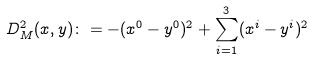<formula> <loc_0><loc_0><loc_500><loc_500>D ^ { 2 } _ { M } ( x , y ) \colon = - ( x ^ { 0 } - y ^ { 0 } ) ^ { 2 } + \sum _ { i = 1 } ^ { 3 } ( x ^ { i } - y ^ { i } ) ^ { 2 }</formula> 